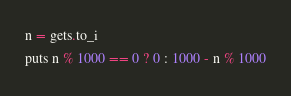Convert code to text. <code><loc_0><loc_0><loc_500><loc_500><_Ruby_>n = gets.to_i
puts n % 1000 == 0 ? 0 : 1000 - n % 1000</code> 